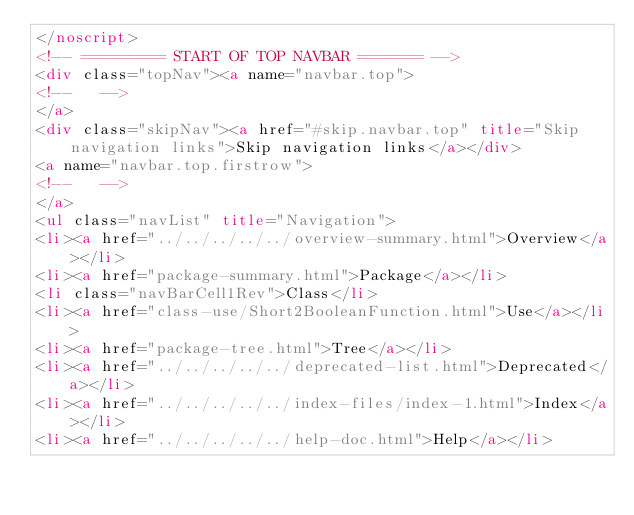<code> <loc_0><loc_0><loc_500><loc_500><_HTML_></noscript>
<!-- ========= START OF TOP NAVBAR ======= -->
<div class="topNav"><a name="navbar.top">
<!--   -->
</a>
<div class="skipNav"><a href="#skip.navbar.top" title="Skip navigation links">Skip navigation links</a></div>
<a name="navbar.top.firstrow">
<!--   -->
</a>
<ul class="navList" title="Navigation">
<li><a href="../../../../../overview-summary.html">Overview</a></li>
<li><a href="package-summary.html">Package</a></li>
<li class="navBarCell1Rev">Class</li>
<li><a href="class-use/Short2BooleanFunction.html">Use</a></li>
<li><a href="package-tree.html">Tree</a></li>
<li><a href="../../../../../deprecated-list.html">Deprecated</a></li>
<li><a href="../../../../../index-files/index-1.html">Index</a></li>
<li><a href="../../../../../help-doc.html">Help</a></li></code> 